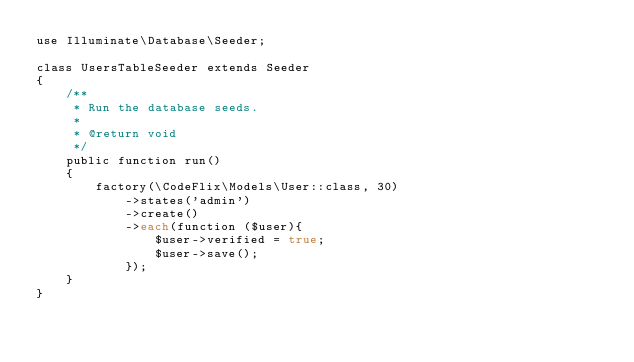Convert code to text. <code><loc_0><loc_0><loc_500><loc_500><_PHP_>use Illuminate\Database\Seeder;

class UsersTableSeeder extends Seeder
{
    /**
     * Run the database seeds.
     *
     * @return void
     */
    public function run()
    {
        factory(\CodeFlix\Models\User::class, 30)
            ->states('admin')
            ->create()
            ->each(function ($user){
                $user->verified = true;
                $user->save();
            });
    }
}
</code> 